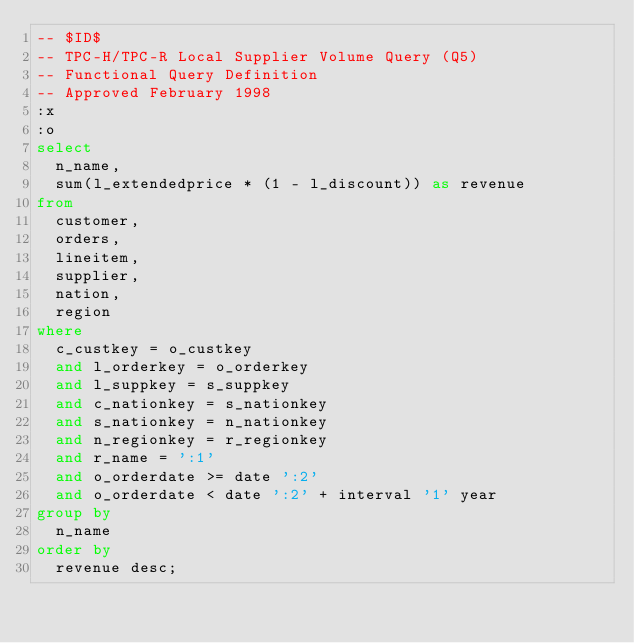<code> <loc_0><loc_0><loc_500><loc_500><_SQL_>-- $ID$
-- TPC-H/TPC-R Local Supplier Volume Query (Q5)
-- Functional Query Definition
-- Approved February 1998
:x
:o
select
	n_name,
	sum(l_extendedprice * (1 - l_discount)) as revenue
from
	customer,
	orders,
	lineitem,
	supplier,
	nation,
	region
where
	c_custkey = o_custkey
	and l_orderkey = o_orderkey
	and l_suppkey = s_suppkey
	and c_nationkey = s_nationkey
	and s_nationkey = n_nationkey
	and n_regionkey = r_regionkey
	and r_name = ':1'
	and o_orderdate >= date ':2'
	and o_orderdate < date ':2' + interval '1' year
group by
	n_name
order by
	revenue desc;
</code> 